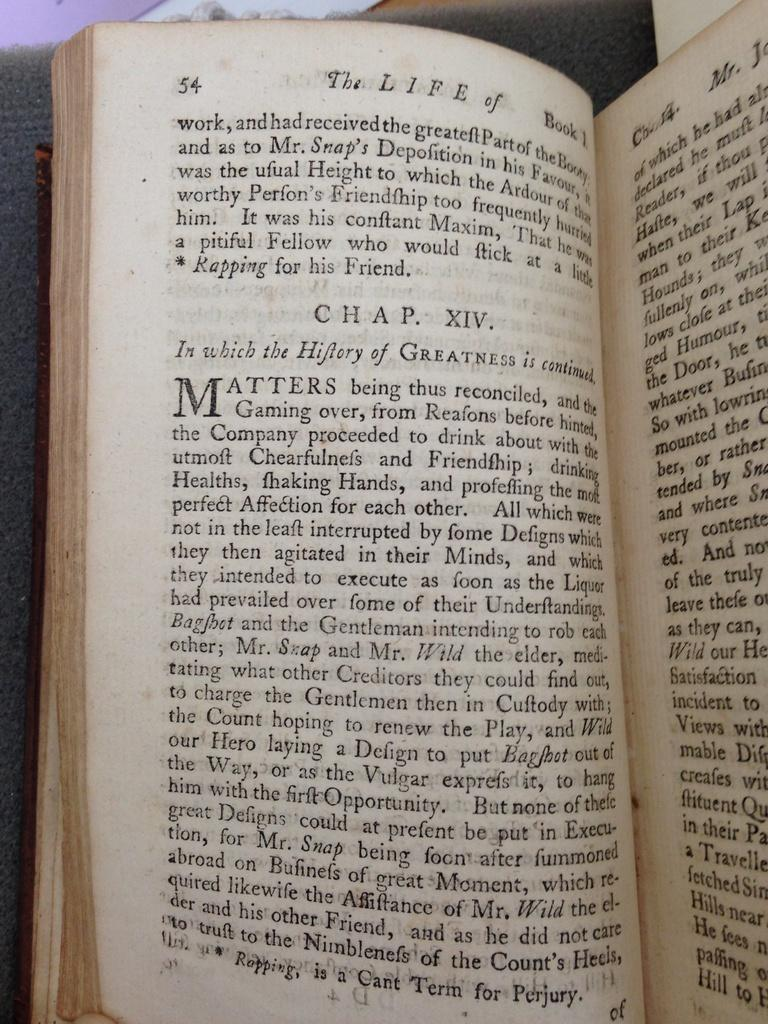<image>
Relay a brief, clear account of the picture shown. A book called The Life Of is open to page 54. 